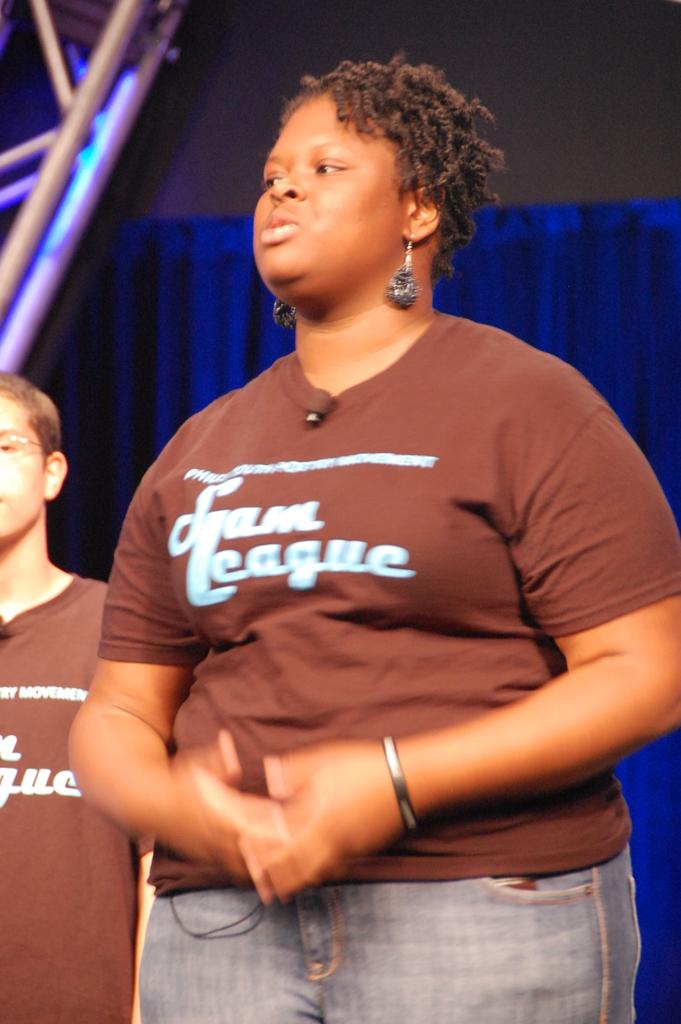<image>
Relay a brief, clear account of the picture shown. a lady in a brown shirt with the word league on it 